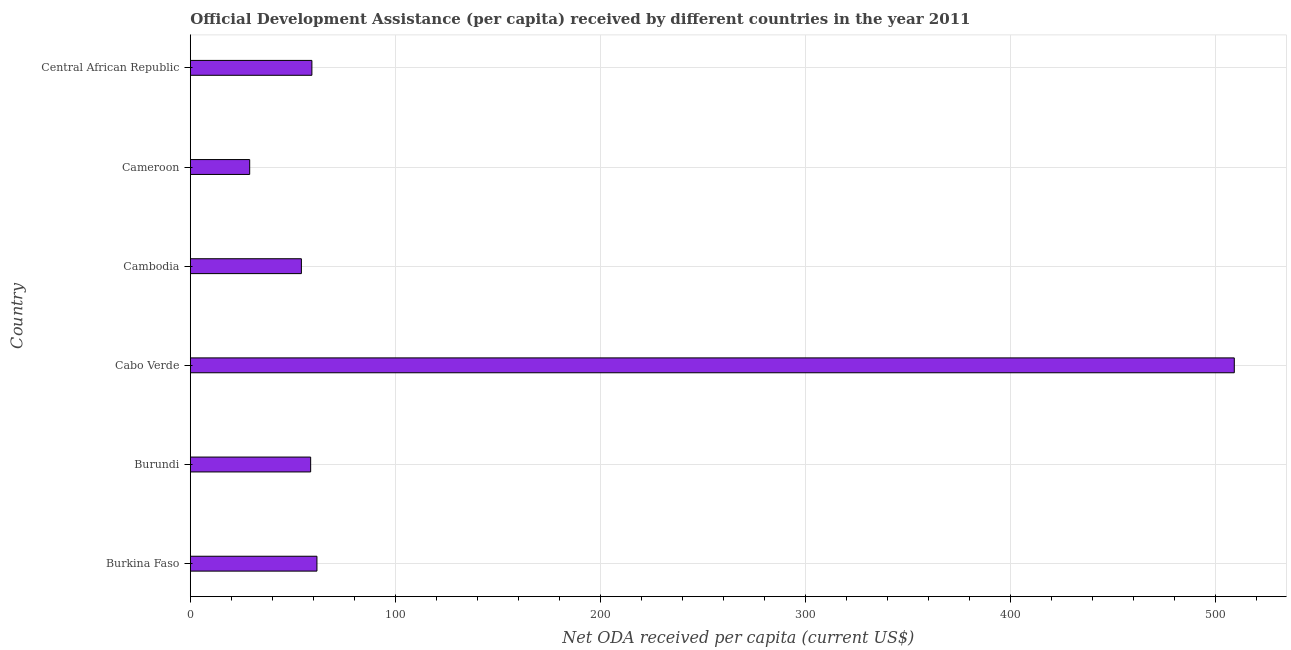Does the graph contain any zero values?
Ensure brevity in your answer.  No. What is the title of the graph?
Offer a terse response. Official Development Assistance (per capita) received by different countries in the year 2011. What is the label or title of the X-axis?
Ensure brevity in your answer.  Net ODA received per capita (current US$). What is the net oda received per capita in Burkina Faso?
Offer a terse response. 61.78. Across all countries, what is the maximum net oda received per capita?
Your answer should be very brief. 509.29. Across all countries, what is the minimum net oda received per capita?
Keep it short and to the point. 28.97. In which country was the net oda received per capita maximum?
Give a very brief answer. Cabo Verde. In which country was the net oda received per capita minimum?
Provide a succinct answer. Cameroon. What is the sum of the net oda received per capita?
Keep it short and to the point. 772.28. What is the difference between the net oda received per capita in Burundi and Cameroon?
Keep it short and to the point. 29.75. What is the average net oda received per capita per country?
Give a very brief answer. 128.71. What is the median net oda received per capita?
Your response must be concise. 59.02. What is the ratio of the net oda received per capita in Cameroon to that in Central African Republic?
Your response must be concise. 0.49. What is the difference between the highest and the second highest net oda received per capita?
Your response must be concise. 447.51. Is the sum of the net oda received per capita in Cabo Verde and Central African Republic greater than the maximum net oda received per capita across all countries?
Give a very brief answer. Yes. What is the difference between the highest and the lowest net oda received per capita?
Ensure brevity in your answer.  480.32. In how many countries, is the net oda received per capita greater than the average net oda received per capita taken over all countries?
Make the answer very short. 1. Are the values on the major ticks of X-axis written in scientific E-notation?
Offer a very short reply. No. What is the Net ODA received per capita (current US$) of Burkina Faso?
Make the answer very short. 61.78. What is the Net ODA received per capita (current US$) of Burundi?
Make the answer very short. 58.72. What is the Net ODA received per capita (current US$) in Cabo Verde?
Provide a short and direct response. 509.29. What is the Net ODA received per capita (current US$) of Cambodia?
Give a very brief answer. 54.2. What is the Net ODA received per capita (current US$) of Cameroon?
Ensure brevity in your answer.  28.97. What is the Net ODA received per capita (current US$) in Central African Republic?
Ensure brevity in your answer.  59.32. What is the difference between the Net ODA received per capita (current US$) in Burkina Faso and Burundi?
Make the answer very short. 3.07. What is the difference between the Net ODA received per capita (current US$) in Burkina Faso and Cabo Verde?
Give a very brief answer. -447.51. What is the difference between the Net ODA received per capita (current US$) in Burkina Faso and Cambodia?
Offer a very short reply. 7.58. What is the difference between the Net ODA received per capita (current US$) in Burkina Faso and Cameroon?
Provide a succinct answer. 32.81. What is the difference between the Net ODA received per capita (current US$) in Burkina Faso and Central African Republic?
Give a very brief answer. 2.47. What is the difference between the Net ODA received per capita (current US$) in Burundi and Cabo Verde?
Your answer should be very brief. -450.57. What is the difference between the Net ODA received per capita (current US$) in Burundi and Cambodia?
Ensure brevity in your answer.  4.52. What is the difference between the Net ODA received per capita (current US$) in Burundi and Cameroon?
Provide a short and direct response. 29.75. What is the difference between the Net ODA received per capita (current US$) in Burundi and Central African Republic?
Keep it short and to the point. -0.6. What is the difference between the Net ODA received per capita (current US$) in Cabo Verde and Cambodia?
Offer a terse response. 455.09. What is the difference between the Net ODA received per capita (current US$) in Cabo Verde and Cameroon?
Make the answer very short. 480.32. What is the difference between the Net ODA received per capita (current US$) in Cabo Verde and Central African Republic?
Make the answer very short. 449.97. What is the difference between the Net ODA received per capita (current US$) in Cambodia and Cameroon?
Your answer should be compact. 25.23. What is the difference between the Net ODA received per capita (current US$) in Cambodia and Central African Republic?
Your response must be concise. -5.12. What is the difference between the Net ODA received per capita (current US$) in Cameroon and Central African Republic?
Your response must be concise. -30.35. What is the ratio of the Net ODA received per capita (current US$) in Burkina Faso to that in Burundi?
Give a very brief answer. 1.05. What is the ratio of the Net ODA received per capita (current US$) in Burkina Faso to that in Cabo Verde?
Ensure brevity in your answer.  0.12. What is the ratio of the Net ODA received per capita (current US$) in Burkina Faso to that in Cambodia?
Your response must be concise. 1.14. What is the ratio of the Net ODA received per capita (current US$) in Burkina Faso to that in Cameroon?
Keep it short and to the point. 2.13. What is the ratio of the Net ODA received per capita (current US$) in Burkina Faso to that in Central African Republic?
Your response must be concise. 1.04. What is the ratio of the Net ODA received per capita (current US$) in Burundi to that in Cabo Verde?
Your answer should be compact. 0.12. What is the ratio of the Net ODA received per capita (current US$) in Burundi to that in Cambodia?
Offer a very short reply. 1.08. What is the ratio of the Net ODA received per capita (current US$) in Burundi to that in Cameroon?
Give a very brief answer. 2.03. What is the ratio of the Net ODA received per capita (current US$) in Cabo Verde to that in Cambodia?
Provide a short and direct response. 9.4. What is the ratio of the Net ODA received per capita (current US$) in Cabo Verde to that in Cameroon?
Make the answer very short. 17.58. What is the ratio of the Net ODA received per capita (current US$) in Cabo Verde to that in Central African Republic?
Give a very brief answer. 8.59. What is the ratio of the Net ODA received per capita (current US$) in Cambodia to that in Cameroon?
Offer a terse response. 1.87. What is the ratio of the Net ODA received per capita (current US$) in Cambodia to that in Central African Republic?
Give a very brief answer. 0.91. What is the ratio of the Net ODA received per capita (current US$) in Cameroon to that in Central African Republic?
Provide a succinct answer. 0.49. 